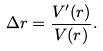Convert formula to latex. <formula><loc_0><loc_0><loc_500><loc_500>\Delta r = \frac { V ^ { \prime } ( r ) } { V ( r ) } .</formula> 